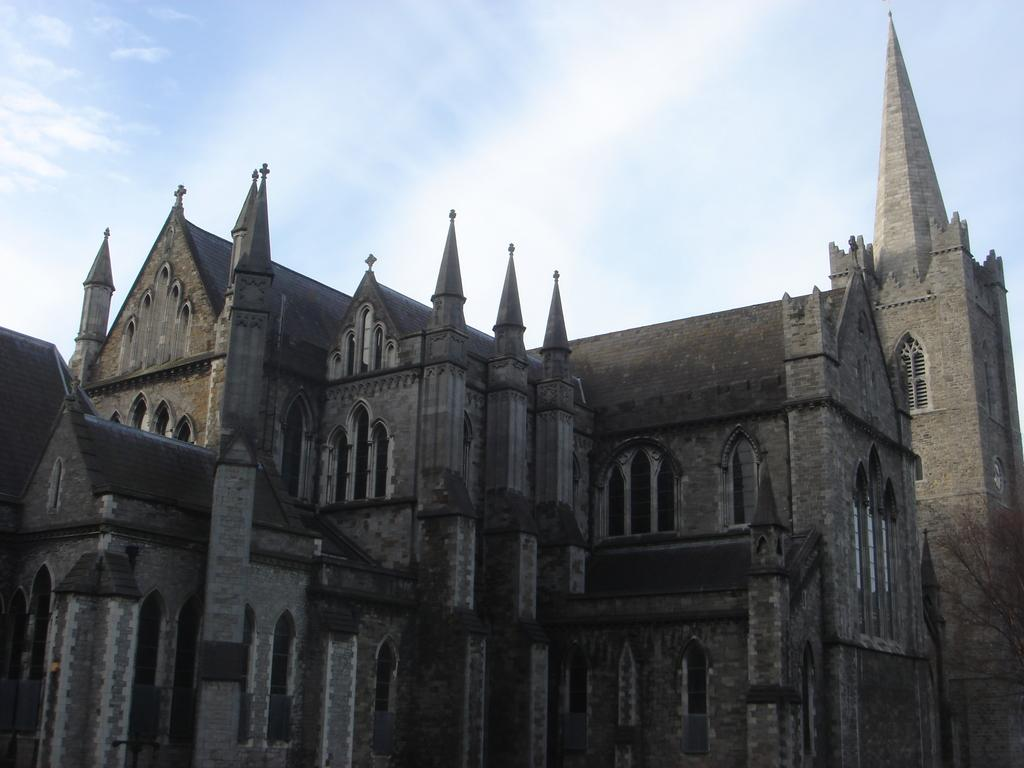What is the main structure in the center of the image? There is a palace in the center of the image. What architectural feature can be seen on the palace? Windows are visible in the image. What is visible at the top of the image? The sky is visible at the top of the image. How is the palace being sorted in the image? The palace is not being sorted in the image; it is a stationary structure. What type of glue is being used to hold the palace together in the image? There is no glue present in the image, as the palace is a solid structure. 